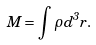Convert formula to latex. <formula><loc_0><loc_0><loc_500><loc_500>M = \int \rho d ^ { 3 } { r } .</formula> 